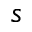Convert formula to latex. <formula><loc_0><loc_0><loc_500><loc_500>s</formula> 